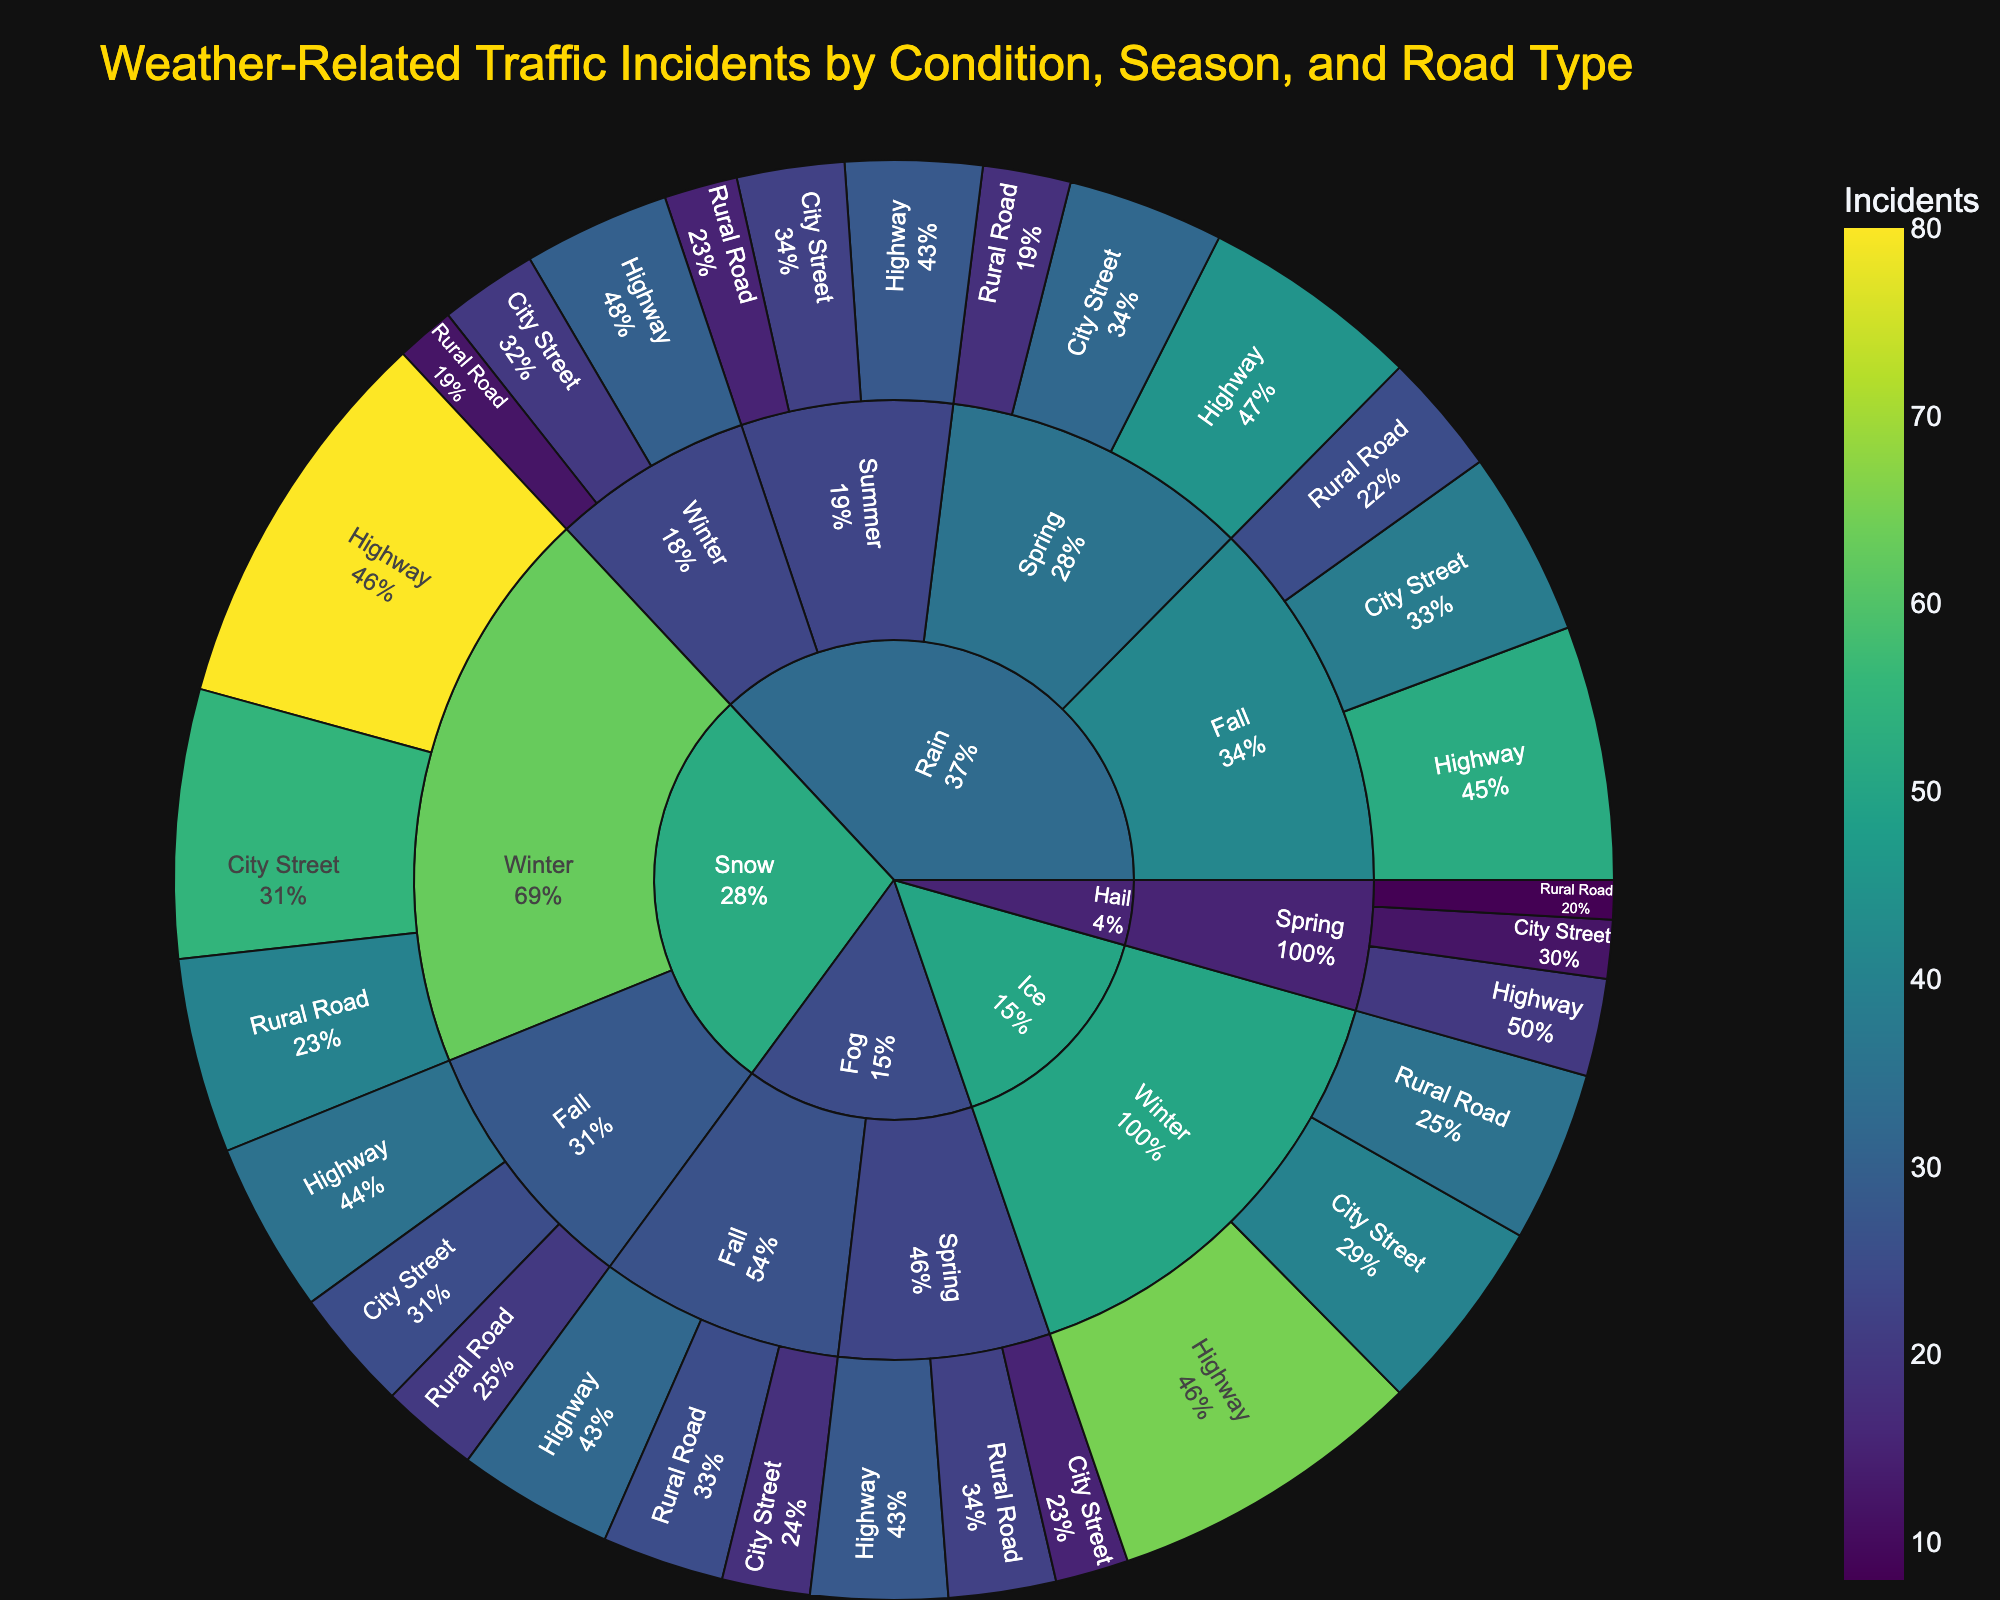What is the title of the plot? The title of the plot is located at the top and is the largest text element, designed to indicate the main topic of the visualization.
Answer: Weather-Related Traffic Incidents by Condition, Season, and Road Type Which weather condition has the highest number of incidents in Winter? Look for the segment under 'Winter' in the sunburst plot where the incidents are depicted by color intensity. Identify which weather-related segment has the most readable or highest value.
Answer: Snow How many total incidents occurred on highways during the Fall season? Sum the incidents from each weather condition i.e., Rain, Snow, and Fog that occurred on highways in the Fall season.
Answer: 119 Which season has the highest number of traffic incidents under various weather conditions? By examining the subdivision of segments for each weather condition, we observe the percentages and total sizes of segments for each season. Identify which season’s segment areas are largest or most predominant.
Answer: Winter Compare the number of traffic incidents on rural roads during Spring for rain and fog conditions. Which one is higher and by how much? Look at the segments for both Rain and Fog under 'Spring' season and 'Rural Road' type. Subtract the incidents for Fog from those for Rain.
Answer: Rain is higher by 18-22 = -4 (Fog higher by 4) What percentage of incidents on city streets under rain conditions occurred in Fall? Locate the segment for 'Rain' > 'Fall' > 'City Street' and read the given percentage compared to all incidents under Rain conditions.
Answer: 38% Is the number of incidents higher on highways during Winter or Fall under icy conditions? Find the appropriate segment under Ice conditions for both Winter and Fall and compare the numbers in each.
Answer: Winter Add the total number of incidents for Hail condition across all listed road types. What is the sum? Sum the incidents from the Hail condition segment for each road type (Highway, City Street, Rural Road) listed in Spring.
Answer: 40 Which road type has the least number of incidents in Winter under Rain conditions? Look at the Rain > Winter segment and compare the number of incidents for Highway, City Street, and Rural Road to find the one with the lowest number.
Answer: Rural Road How does the number of incidents on highways during rainy Summer compare to those in rainy Winter? Identify the segments for Rain > Summer > Highway and Rain > Winter > Highway and compare their incident counts directly.
Answer: Winter has more incidents (30) than Summer (28) 